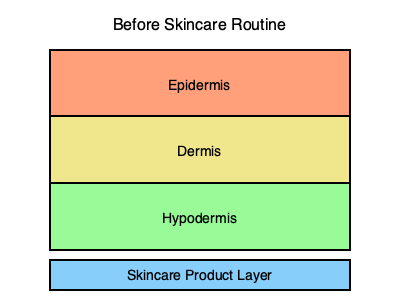Based on the diagram showing the layers of skin before a skincare routine, how would the appearance change after applying a moisturizing product? Which layer would be most affected, and how would you visually represent this change? To answer this question, let's consider the effects of a moisturizing product on the skin layers:

1. The skincare product is applied to the surface of the skin, creating a new layer on top of the epidermis.

2. The primary target of most moisturizers is the epidermis, the outermost layer of the skin.

3. When a moisturizer is applied:
   a) It forms a protective barrier on the skin's surface.
   b) It helps to hydrate the epidermis by drawing water into this layer.
   c) Some ingredients may penetrate deeper, but the most significant visible effects occur in the epidermis.

4. To visually represent this change:
   a) Add a thin layer on top of the existing layers to represent the applied product.
   b) The epidermis layer should appear slightly thicker and more hydrated.
   c) The color of the epidermis could be adjusted to a slightly darker or more vibrant shade to represent increased hydration.

5. The dermis and hypodermis would remain largely unchanged in appearance, as the immediate effects of topical moisturizers are primarily on the epidermis.

Therefore, the most affected layer would be the epidermis, and the visual representation would include a new top layer for the product and a slightly thicker, more vibrant epidermis layer.
Answer: Epidermis thicker and more vibrant, new product layer on top 